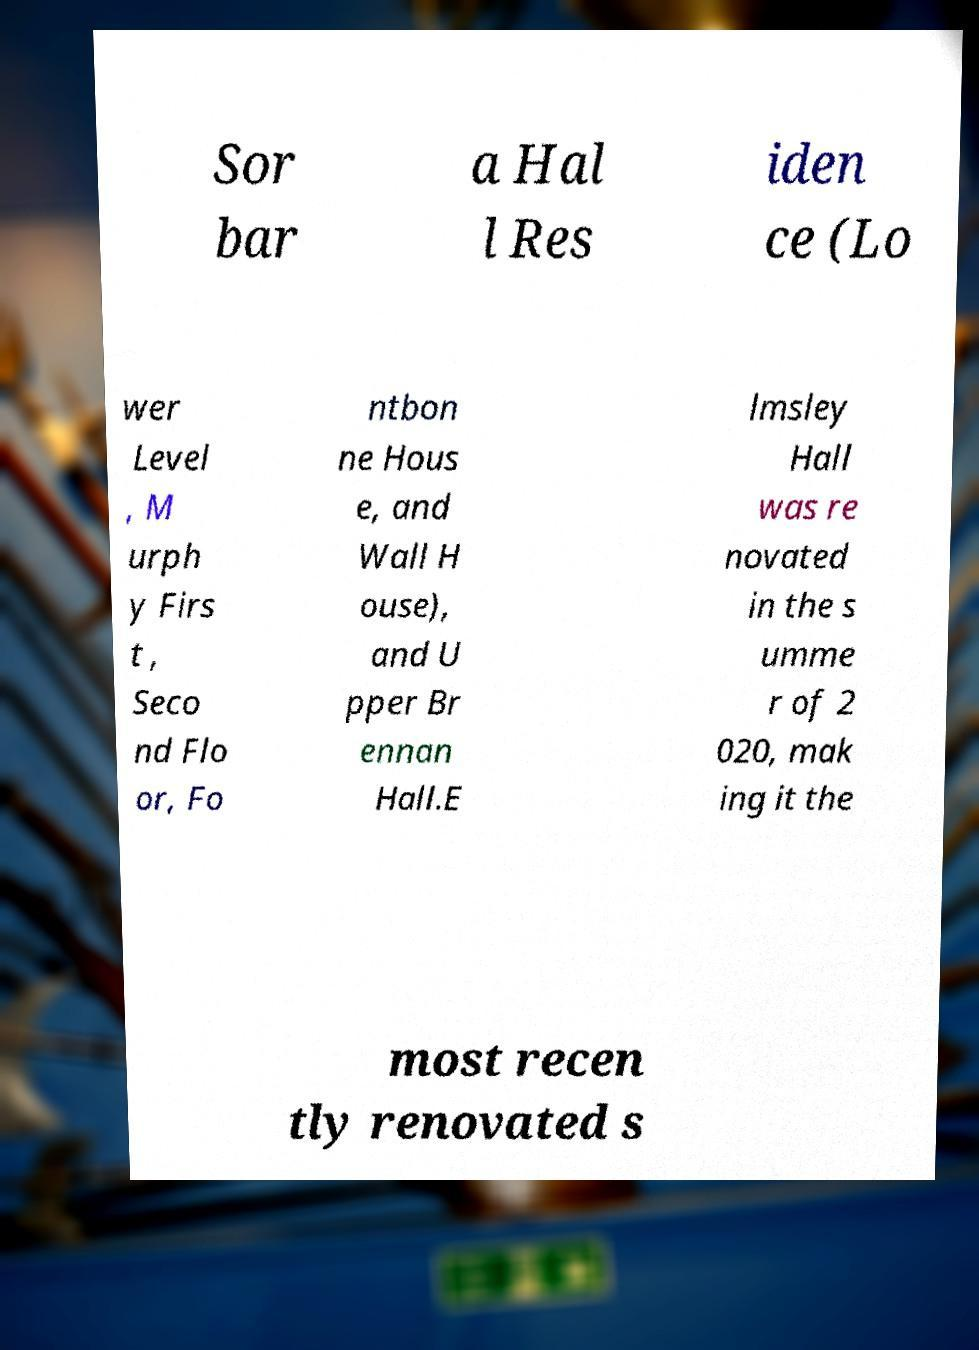There's text embedded in this image that I need extracted. Can you transcribe it verbatim? Sor bar a Hal l Res iden ce (Lo wer Level , M urph y Firs t , Seco nd Flo or, Fo ntbon ne Hous e, and Wall H ouse), and U pper Br ennan Hall.E lmsley Hall was re novated in the s umme r of 2 020, mak ing it the most recen tly renovated s 